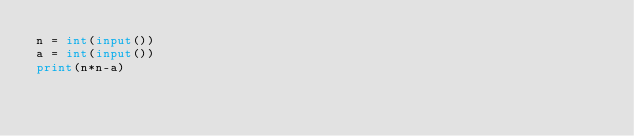<code> <loc_0><loc_0><loc_500><loc_500><_Python_>n = int(input())
a = int(input())
print(n*n-a)</code> 